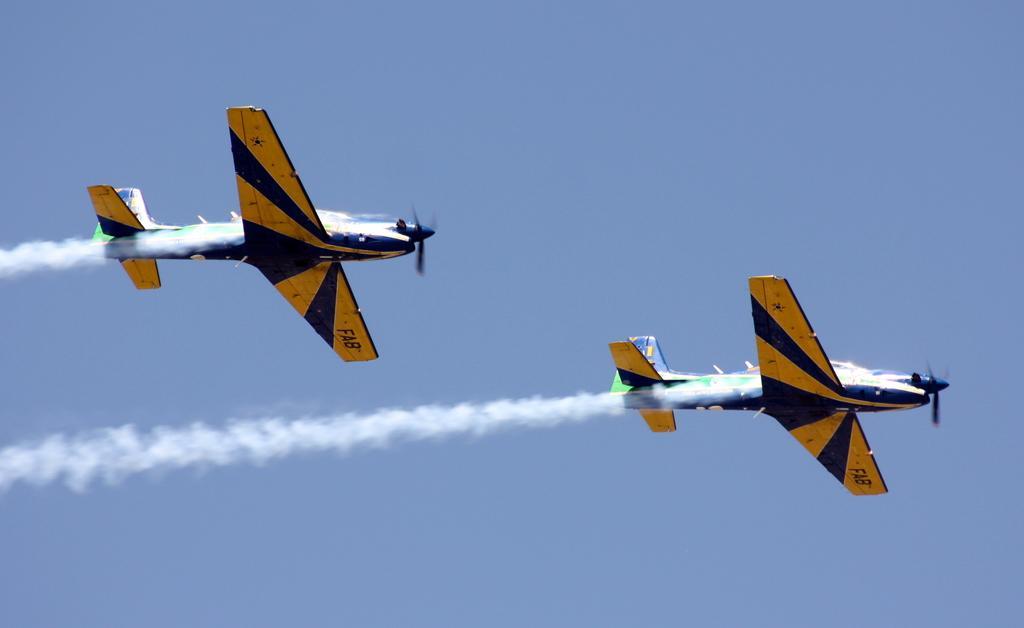Could you give a brief overview of what you see in this image? There are two planes flying in the air and leaving smoke at back of it. 